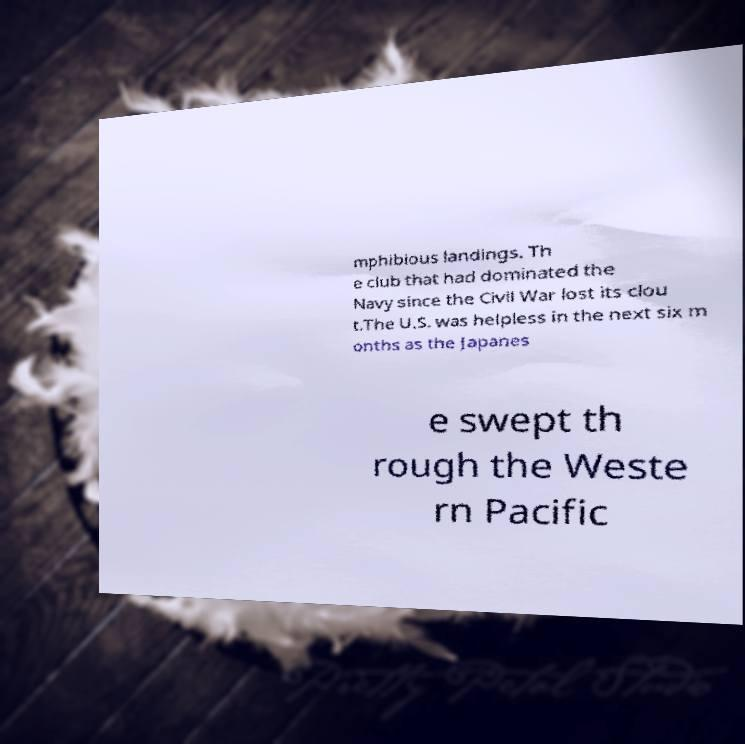I need the written content from this picture converted into text. Can you do that? mphibious landings. Th e club that had dominated the Navy since the Civil War lost its clou t.The U.S. was helpless in the next six m onths as the Japanes e swept th rough the Weste rn Pacific 